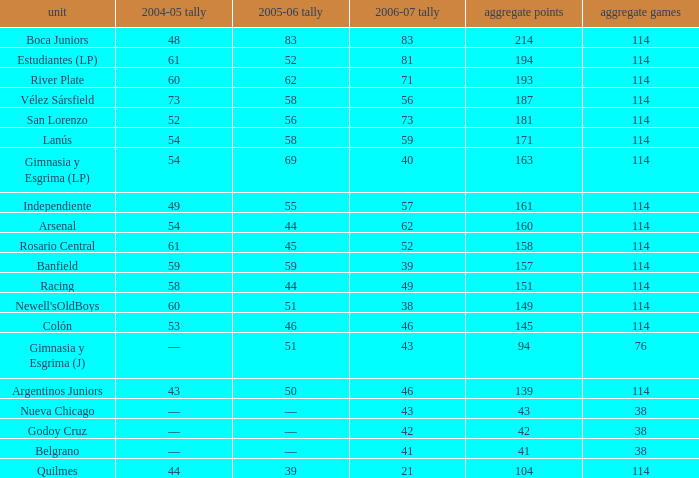What is the overall pld with 158 points in 2006-07, and below 52 points in 2006-07? None. 